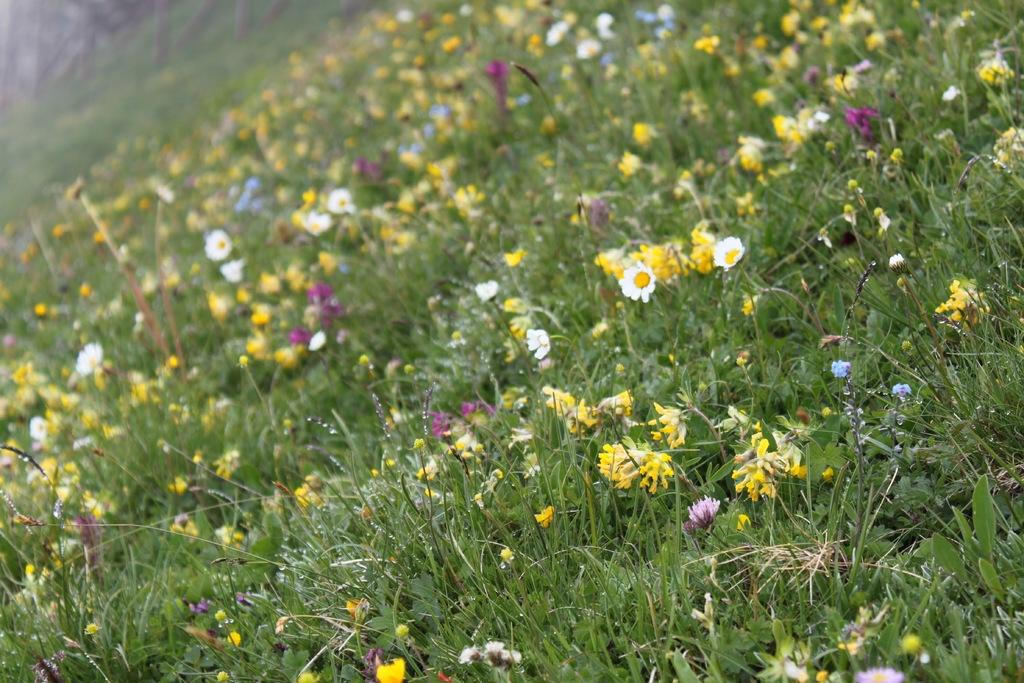What type of living organisms can be seen in the image? The image contains plants and flowers. Can you describe the flowers in the image? The flowers are present with the plants in the image. How many kittens are attempting to serve the flowers in the image? There are no kittens or attempts to serve the flowers in the image; it only contains plants and flowers. 